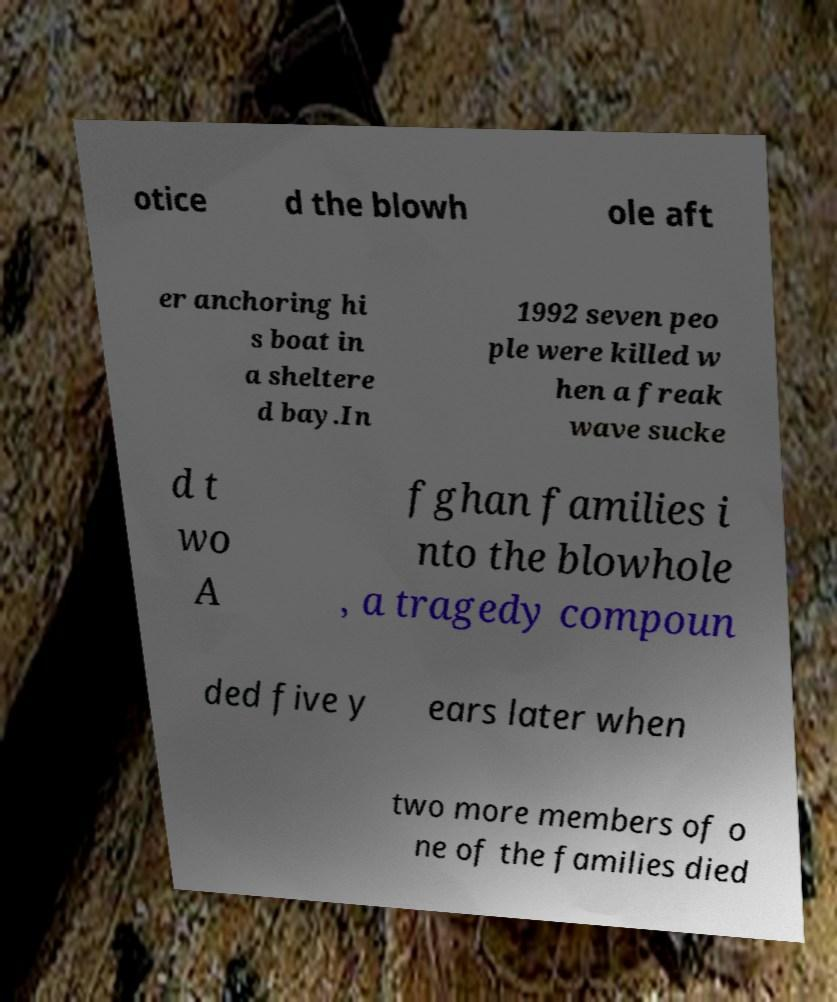Can you read and provide the text displayed in the image?This photo seems to have some interesting text. Can you extract and type it out for me? otice d the blowh ole aft er anchoring hi s boat in a sheltere d bay.In 1992 seven peo ple were killed w hen a freak wave sucke d t wo A fghan families i nto the blowhole , a tragedy compoun ded five y ears later when two more members of o ne of the families died 